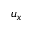Convert formula to latex. <formula><loc_0><loc_0><loc_500><loc_500>u _ { x }</formula> 